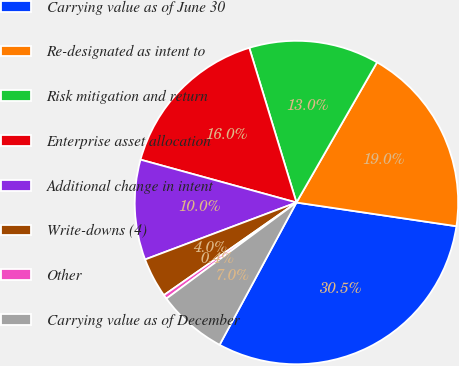Convert chart to OTSL. <chart><loc_0><loc_0><loc_500><loc_500><pie_chart><fcel>Carrying value as of June 30<fcel>Re-designated as intent to<fcel>Risk mitigation and return<fcel>Enterprise asset allocation<fcel>Additional change in intent<fcel>Write-downs (4)<fcel>Other<fcel>Carrying value as of December<nl><fcel>30.54%<fcel>19.04%<fcel>13.01%<fcel>16.02%<fcel>10.0%<fcel>3.98%<fcel>0.42%<fcel>6.99%<nl></chart> 